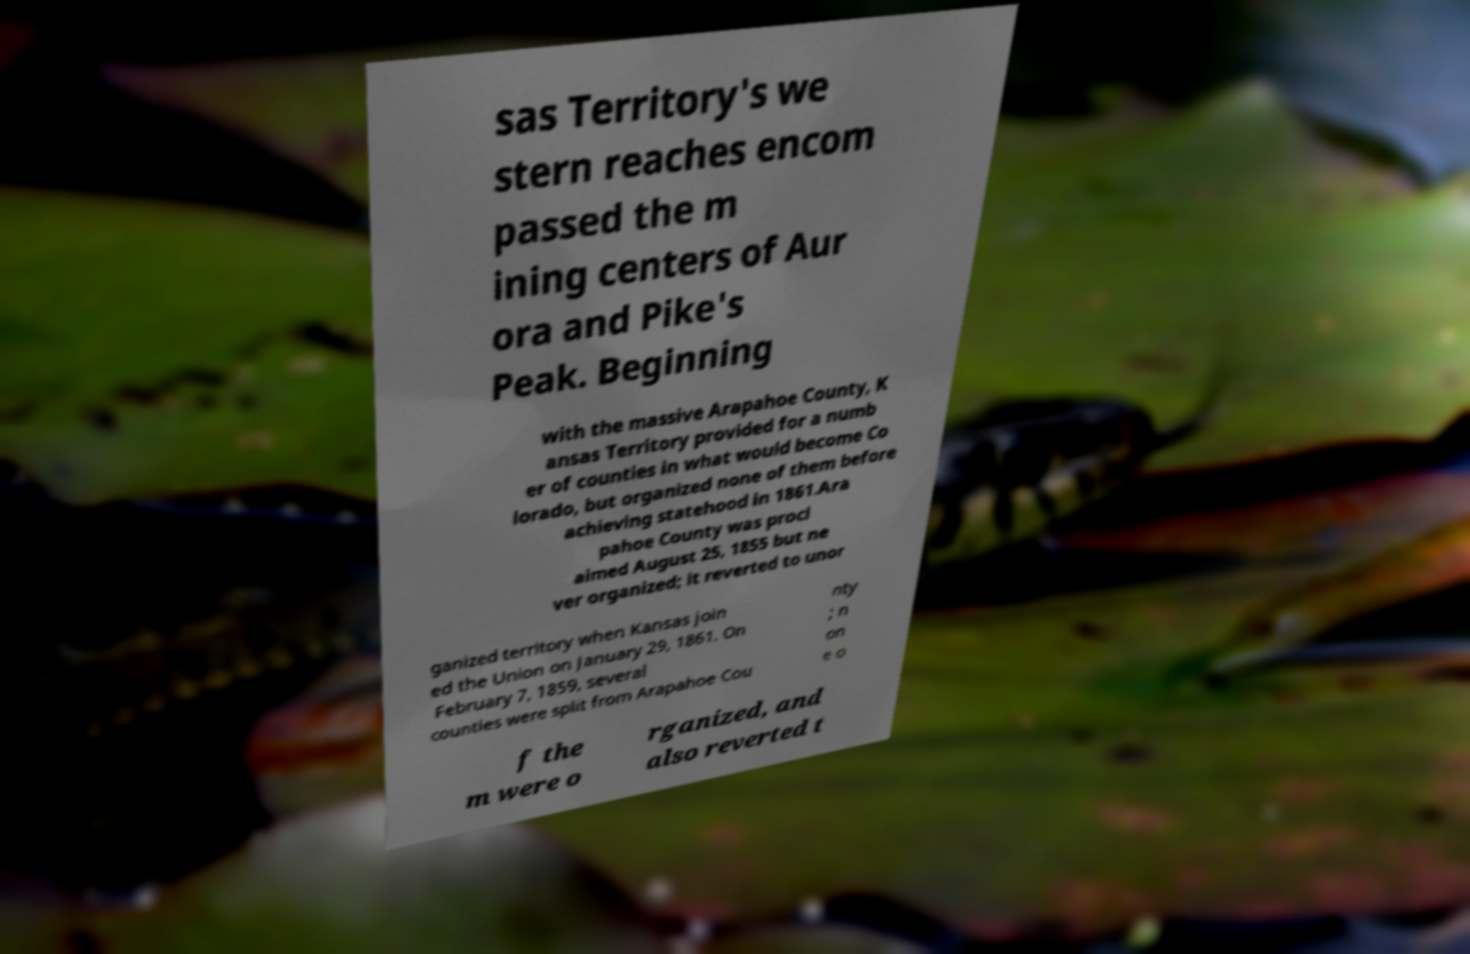Please read and relay the text visible in this image. What does it say? sas Territory's we stern reaches encom passed the m ining centers of Aur ora and Pike's Peak. Beginning with the massive Arapahoe County, K ansas Territory provided for a numb er of counties in what would become Co lorado, but organized none of them before achieving statehood in 1861.Ara pahoe County was procl aimed August 25, 1855 but ne ver organized; it reverted to unor ganized territory when Kansas join ed the Union on January 29, 1861. On February 7, 1859, several counties were split from Arapahoe Cou nty ; n on e o f the m were o rganized, and also reverted t 